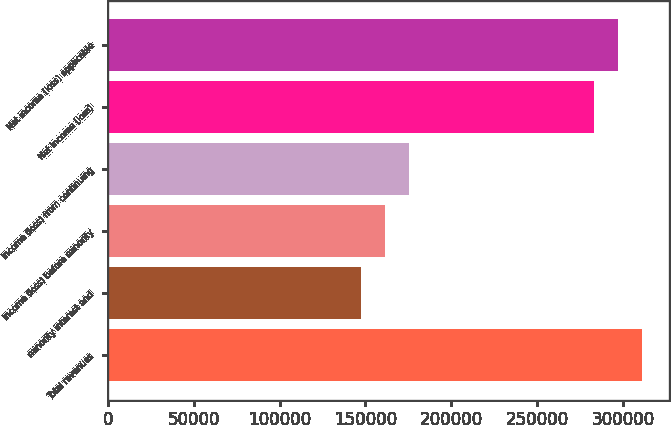Convert chart to OTSL. <chart><loc_0><loc_0><loc_500><loc_500><bar_chart><fcel>Total revenues<fcel>minority interest and<fcel>Income (loss) before minority<fcel>Income (loss) from continuing<fcel>Net income (loss)<fcel>Net income (loss) applicable<nl><fcel>311162<fcel>147428<fcel>161483<fcel>175539<fcel>283051<fcel>297106<nl></chart> 